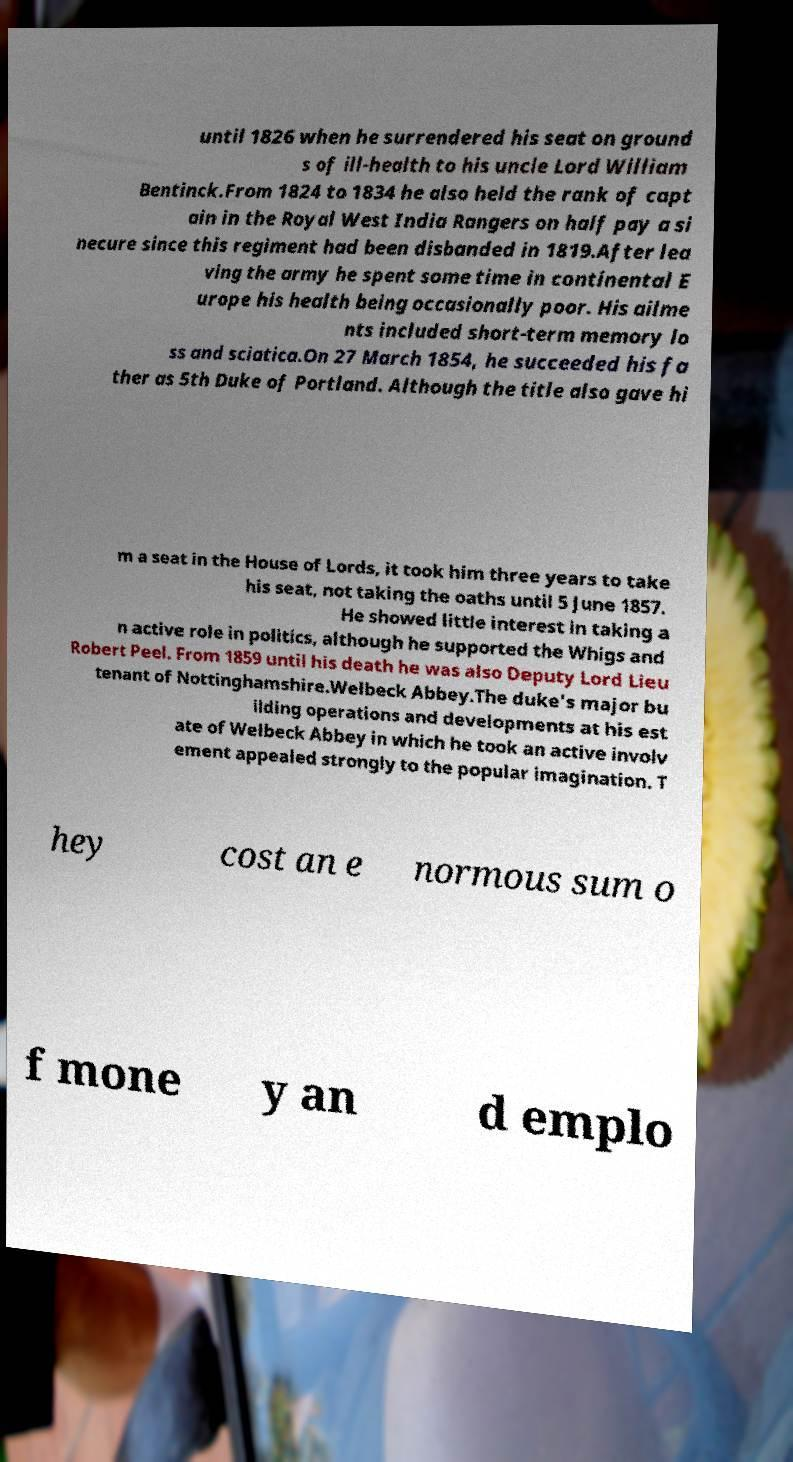Please identify and transcribe the text found in this image. until 1826 when he surrendered his seat on ground s of ill-health to his uncle Lord William Bentinck.From 1824 to 1834 he also held the rank of capt ain in the Royal West India Rangers on half pay a si necure since this regiment had been disbanded in 1819.After lea ving the army he spent some time in continental E urope his health being occasionally poor. His ailme nts included short-term memory lo ss and sciatica.On 27 March 1854, he succeeded his fa ther as 5th Duke of Portland. Although the title also gave hi m a seat in the House of Lords, it took him three years to take his seat, not taking the oaths until 5 June 1857. He showed little interest in taking a n active role in politics, although he supported the Whigs and Robert Peel. From 1859 until his death he was also Deputy Lord Lieu tenant of Nottinghamshire.Welbeck Abbey.The duke's major bu ilding operations and developments at his est ate of Welbeck Abbey in which he took an active involv ement appealed strongly to the popular imagination. T hey cost an e normous sum o f mone y an d emplo 